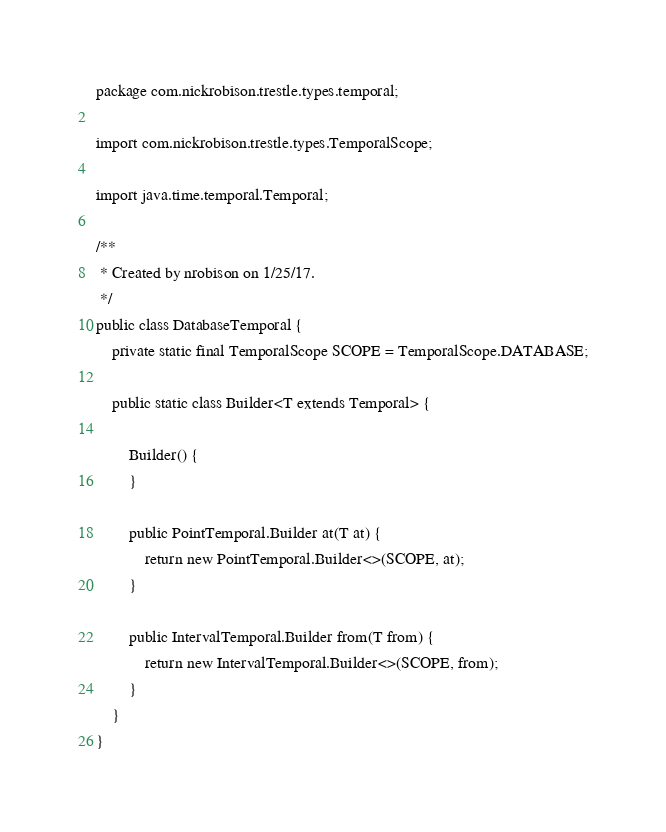Convert code to text. <code><loc_0><loc_0><loc_500><loc_500><_Java_>package com.nickrobison.trestle.types.temporal;

import com.nickrobison.trestle.types.TemporalScope;

import java.time.temporal.Temporal;

/**
 * Created by nrobison on 1/25/17.
 */
public class DatabaseTemporal {
    private static final TemporalScope SCOPE = TemporalScope.DATABASE;

    public static class Builder<T extends Temporal> {

        Builder() {
        }

        public PointTemporal.Builder at(T at) {
            return new PointTemporal.Builder<>(SCOPE, at);
        }

        public IntervalTemporal.Builder from(T from) {
            return new IntervalTemporal.Builder<>(SCOPE, from);
        }
    }
}
</code> 